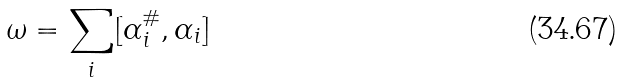<formula> <loc_0><loc_0><loc_500><loc_500>\omega = \sum _ { i } [ \alpha _ { i } ^ { \# } , \alpha _ { i } ]</formula> 